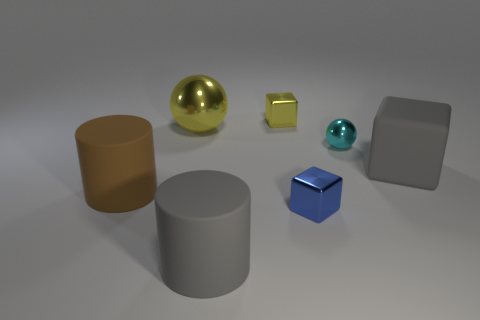Do the large yellow thing and the cyan metal thing behind the blue object have the same shape?
Offer a terse response. Yes. Are there an equal number of rubber things behind the small ball and blocks in front of the gray cube?
Offer a very short reply. No. How many other objects are the same material as the small cyan thing?
Provide a succinct answer. 3. How many shiny objects are either big gray cubes or gray objects?
Keep it short and to the point. 0. Do the gray thing that is behind the blue cube and the small blue shiny thing have the same shape?
Your answer should be very brief. Yes. Is the number of large things that are behind the tiny sphere greater than the number of tiny cyan rubber things?
Your answer should be compact. Yes. What number of objects are on the right side of the large brown thing and in front of the big cube?
Provide a succinct answer. 2. The metal sphere that is to the left of the big gray rubber thing in front of the tiny blue metal block is what color?
Provide a succinct answer. Yellow. How many tiny metallic objects are the same color as the big metal object?
Provide a succinct answer. 1. Do the large block and the cylinder that is behind the small blue object have the same color?
Provide a succinct answer. No. 